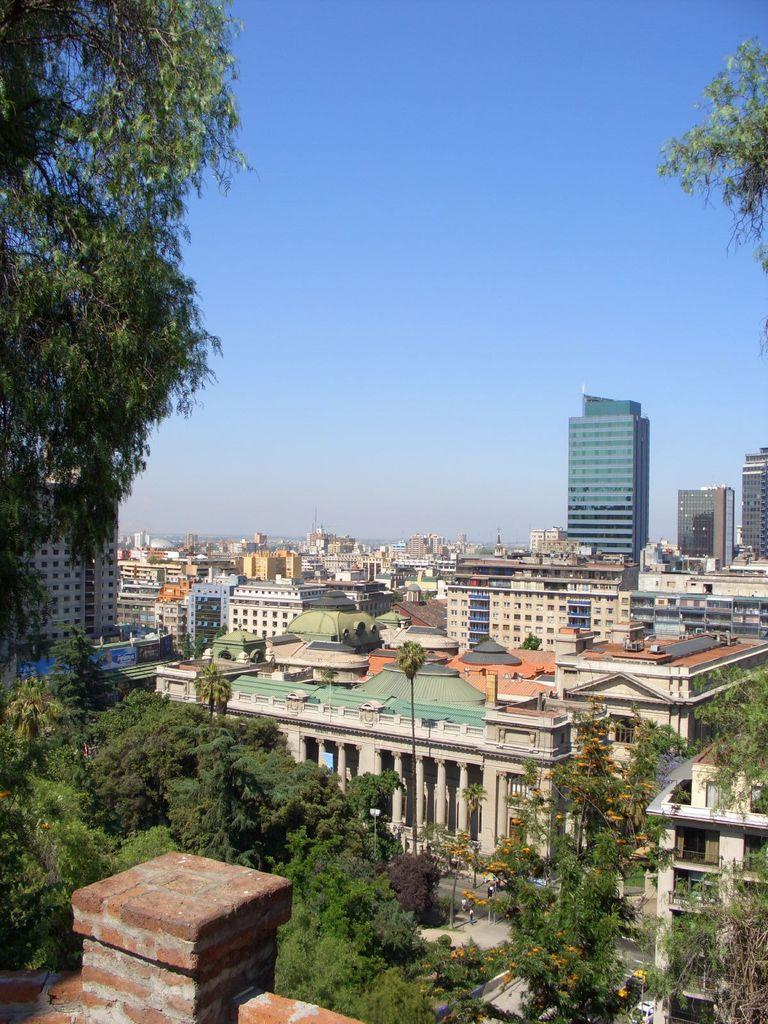What type of structures are present in the image? There are buildings in the image. What other natural elements can be seen in the image? There are trees in the image. What is visible at the top of the image? The sky is visible at the top of the image. What type of haircut is the tree receiving in the image? There is no haircut being given in the image, as trees do not have hair. What type of print can be seen on the buildings in the image? There is no information about the print on the buildings in the image, as the facts provided do not mention any specific prints or designs. 